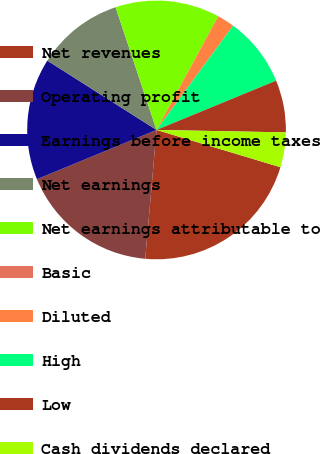Convert chart. <chart><loc_0><loc_0><loc_500><loc_500><pie_chart><fcel>Net revenues<fcel>Operating profit<fcel>Earnings before income taxes<fcel>Net earnings<fcel>Net earnings attributable to<fcel>Basic<fcel>Diluted<fcel>High<fcel>Low<fcel>Cash dividends declared<nl><fcel>21.74%<fcel>17.39%<fcel>15.22%<fcel>10.87%<fcel>13.04%<fcel>0.0%<fcel>2.17%<fcel>8.7%<fcel>6.52%<fcel>4.35%<nl></chart> 